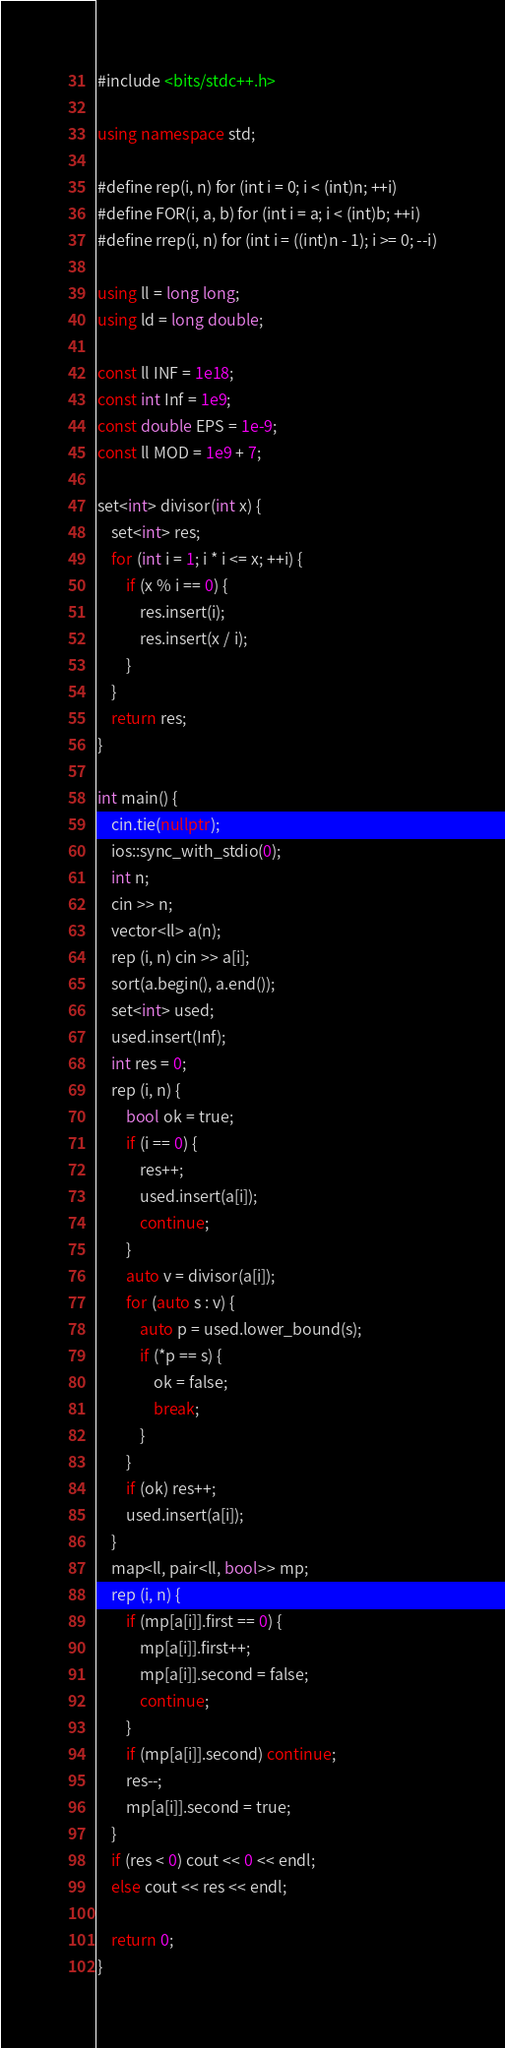Convert code to text. <code><loc_0><loc_0><loc_500><loc_500><_C++_>#include <bits/stdc++.h>

using namespace std;

#define rep(i, n) for (int i = 0; i < (int)n; ++i)
#define FOR(i, a, b) for (int i = a; i < (int)b; ++i)
#define rrep(i, n) for (int i = ((int)n - 1); i >= 0; --i)

using ll = long long;
using ld = long double;

const ll INF = 1e18;
const int Inf = 1e9;
const double EPS = 1e-9;
const ll MOD = 1e9 + 7;

set<int> divisor(int x) {
    set<int> res;
    for (int i = 1; i * i <= x; ++i) {
        if (x % i == 0) {
            res.insert(i);
            res.insert(x / i);
        }
    }
    return res;
}

int main() {
    cin.tie(nullptr);
    ios::sync_with_stdio(0);
    int n;
    cin >> n;
    vector<ll> a(n);
    rep (i, n) cin >> a[i];
    sort(a.begin(), a.end());
    set<int> used;
    used.insert(Inf);
    int res = 0;
    rep (i, n) {
        bool ok = true;
        if (i == 0) {
            res++;
            used.insert(a[i]);
            continue;
        }
        auto v = divisor(a[i]);
        for (auto s : v) {
            auto p = used.lower_bound(s);
            if (*p == s) {
                ok = false;
                break;
            }
        }
        if (ok) res++;
        used.insert(a[i]);
    }
    map<ll, pair<ll, bool>> mp;
    rep (i, n) {
        if (mp[a[i]].first == 0) {
            mp[a[i]].first++;
            mp[a[i]].second = false;
            continue;
        }
        if (mp[a[i]].second) continue;
        res--;
        mp[a[i]].second = true;
    }
    if (res < 0) cout << 0 << endl;
    else cout << res << endl;
    
    return 0;
}

</code> 